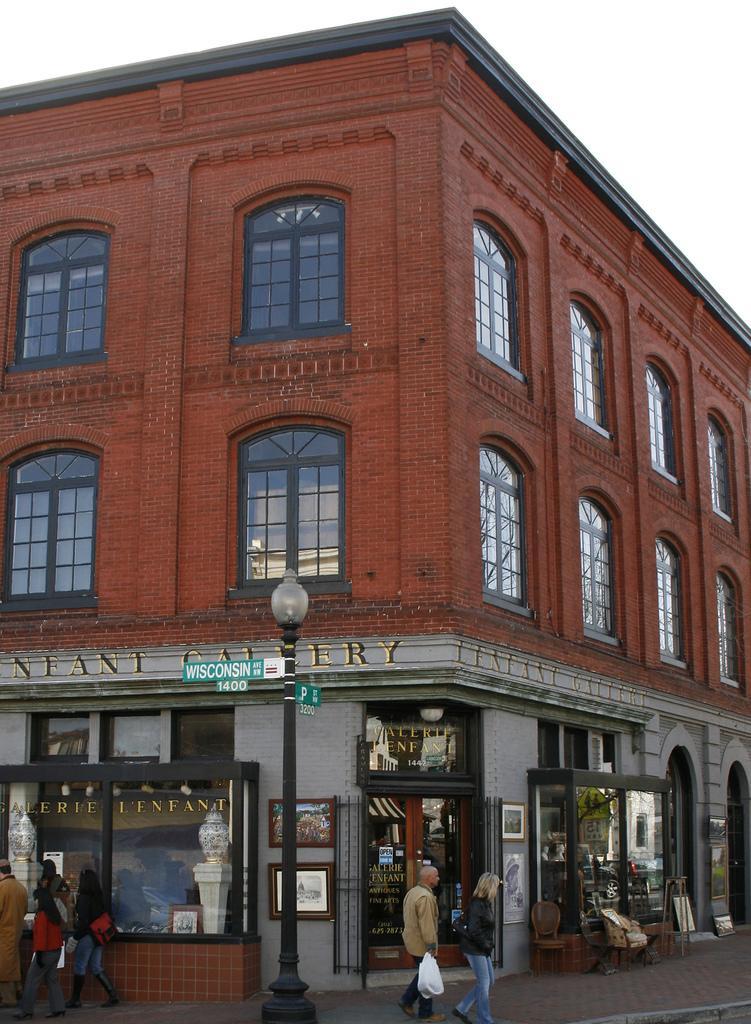Could you give a brief overview of what you see in this image? In this image we can see a building. In front of the building people are walking on the pavement and one pole is there. At the top white color sky is present. 